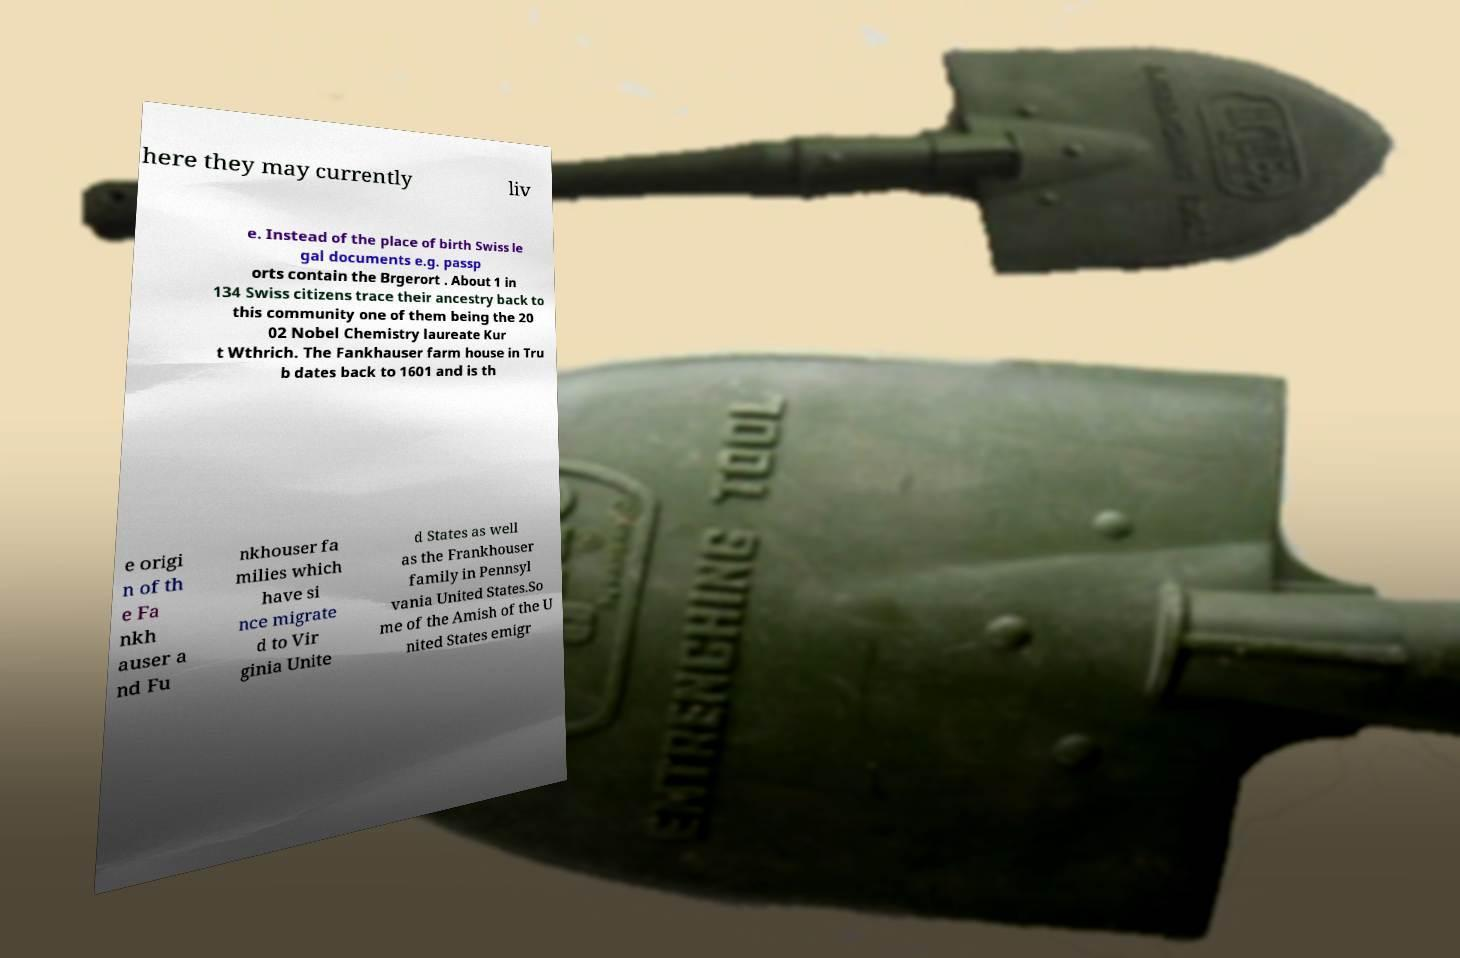Could you assist in decoding the text presented in this image and type it out clearly? here they may currently liv e. Instead of the place of birth Swiss le gal documents e.g. passp orts contain the Brgerort . About 1 in 134 Swiss citizens trace their ancestry back to this community one of them being the 20 02 Nobel Chemistry laureate Kur t Wthrich. The Fankhauser farm house in Tru b dates back to 1601 and is th e origi n of th e Fa nkh auser a nd Fu nkhouser fa milies which have si nce migrate d to Vir ginia Unite d States as well as the Frankhouser family in Pennsyl vania United States.So me of the Amish of the U nited States emigr 